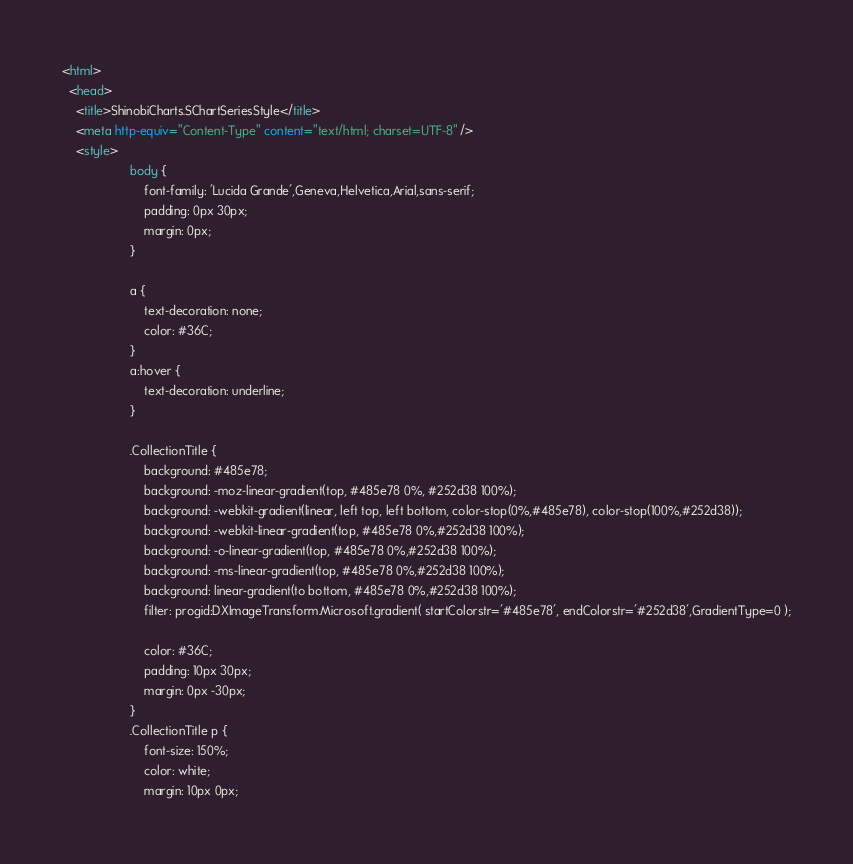Convert code to text. <code><loc_0><loc_0><loc_500><loc_500><_HTML_><html>
  <head>
    <title>ShinobiCharts.SChartSeriesStyle</title>
    <meta http-equiv="Content-Type" content="text/html; charset=UTF-8" />
    <style>
                    body {
                        font-family: 'Lucida Grande',Geneva,Helvetica,Arial,sans-serif;
                        padding: 0px 30px;
                        margin: 0px;
                    }
                    
                    a {
                        text-decoration: none;
                        color: #36C;
                    }
                    a:hover {
                        text-decoration: underline;
                    }
                    
                    .CollectionTitle {
                        background: #485e78;
                        background: -moz-linear-gradient(top, #485e78 0%, #252d38 100%);
                        background: -webkit-gradient(linear, left top, left bottom, color-stop(0%,#485e78), color-stop(100%,#252d38));
                        background: -webkit-linear-gradient(top, #485e78 0%,#252d38 100%);
                        background: -o-linear-gradient(top, #485e78 0%,#252d38 100%);
                        background: -ms-linear-gradient(top, #485e78 0%,#252d38 100%);
                        background: linear-gradient(to bottom, #485e78 0%,#252d38 100%);
                        filter: progid:DXImageTransform.Microsoft.gradient( startColorstr='#485e78', endColorstr='#252d38',GradientType=0 );
                        
                        color: #36C;
                        padding: 10px 30px;
                        margin: 0px -30px;
                    }
                    .CollectionTitle p {
                        font-size: 150%;
                        color: white;
                        margin: 10px 0px;</code> 